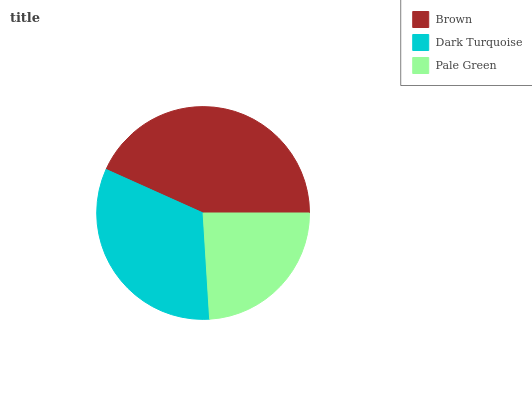Is Pale Green the minimum?
Answer yes or no. Yes. Is Brown the maximum?
Answer yes or no. Yes. Is Dark Turquoise the minimum?
Answer yes or no. No. Is Dark Turquoise the maximum?
Answer yes or no. No. Is Brown greater than Dark Turquoise?
Answer yes or no. Yes. Is Dark Turquoise less than Brown?
Answer yes or no. Yes. Is Dark Turquoise greater than Brown?
Answer yes or no. No. Is Brown less than Dark Turquoise?
Answer yes or no. No. Is Dark Turquoise the high median?
Answer yes or no. Yes. Is Dark Turquoise the low median?
Answer yes or no. Yes. Is Brown the high median?
Answer yes or no. No. Is Pale Green the low median?
Answer yes or no. No. 